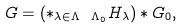Convert formula to latex. <formula><loc_0><loc_0><loc_500><loc_500>G = \left ( \ast _ { \lambda \in \Lambda \ \Lambda _ { 0 } } H _ { \lambda } \right ) \ast G _ { 0 } ,</formula> 